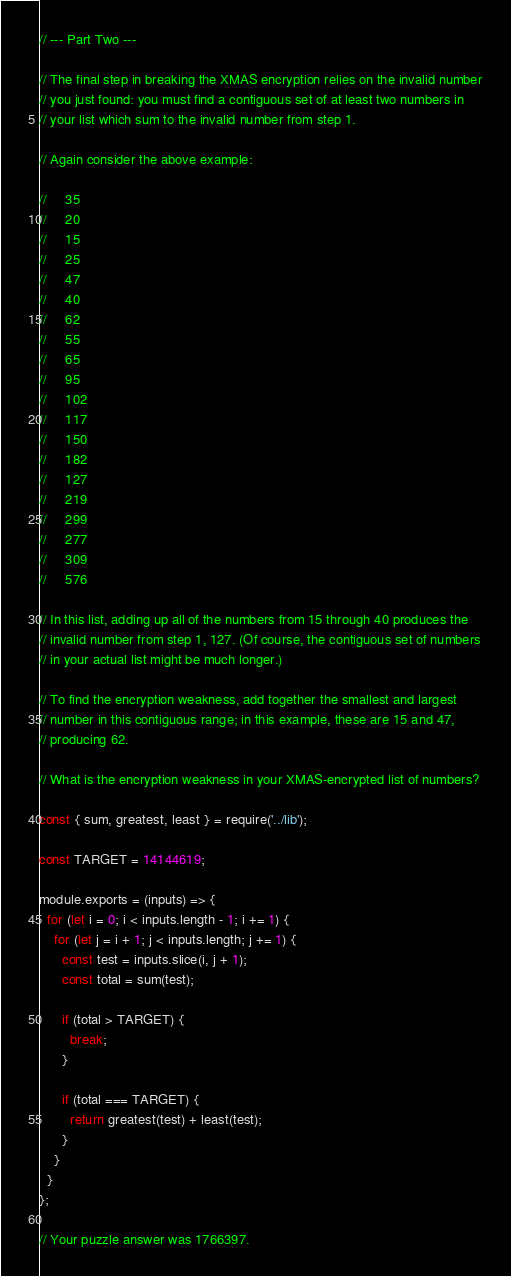Convert code to text. <code><loc_0><loc_0><loc_500><loc_500><_JavaScript_>// --- Part Two ---

// The final step in breaking the XMAS encryption relies on the invalid number
// you just found: you must find a contiguous set of at least two numbers in
// your list which sum to the invalid number from step 1.

// Again consider the above example:

//     35
//     20
//     15
//     25
//     47
//     40
//     62
//     55
//     65
//     95
//     102
//     117
//     150
//     182
//     127
//     219
//     299
//     277
//     309
//     576

// In this list, adding up all of the numbers from 15 through 40 produces the
// invalid number from step 1, 127. (Of course, the contiguous set of numbers
// in your actual list might be much longer.)

// To find the encryption weakness, add together the smallest and largest
// number in this contiguous range; in this example, these are 15 and 47,
// producing 62.

// What is the encryption weakness in your XMAS-encrypted list of numbers?

const { sum, greatest, least } = require('../lib');

const TARGET = 14144619;

module.exports = (inputs) => {
  for (let i = 0; i < inputs.length - 1; i += 1) {
    for (let j = i + 1; j < inputs.length; j += 1) {
      const test = inputs.slice(i, j + 1);
      const total = sum(test);

      if (total > TARGET) {
        break;
      }

      if (total === TARGET) {
        return greatest(test) + least(test);
      }
    }
  }
};

// Your puzzle answer was 1766397.
</code> 